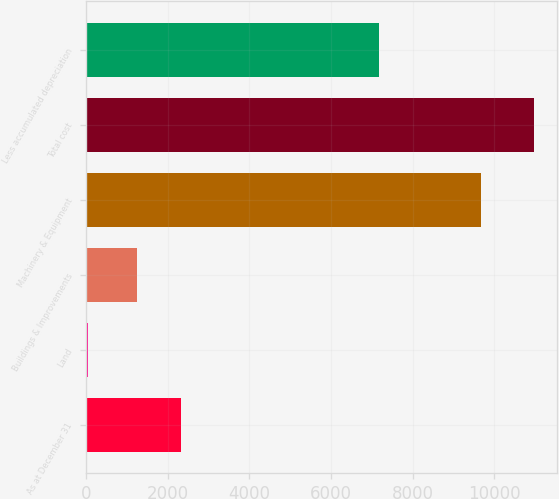Convert chart. <chart><loc_0><loc_0><loc_500><loc_500><bar_chart><fcel>As at December 31<fcel>Land<fcel>Buildings & Improvements<fcel>Machinery & Equipment<fcel>Total cost<fcel>Less accumulated depreciation<nl><fcel>2331.1<fcel>56<fcel>1239<fcel>9682<fcel>10977<fcel>7177<nl></chart> 